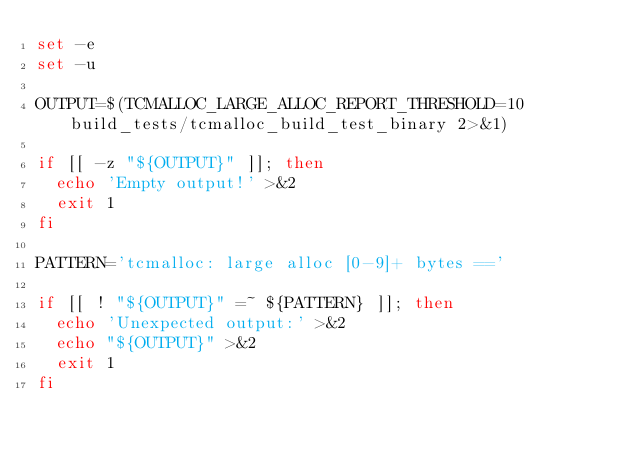Convert code to text. <code><loc_0><loc_0><loc_500><loc_500><_Bash_>set -e
set -u

OUTPUT=$(TCMALLOC_LARGE_ALLOC_REPORT_THRESHOLD=10 build_tests/tcmalloc_build_test_binary 2>&1)

if [[ -z "${OUTPUT}" ]]; then
  echo 'Empty output!' >&2
  exit 1
fi

PATTERN='tcmalloc: large alloc [0-9]+ bytes =='

if [[ ! "${OUTPUT}" =~ ${PATTERN} ]]; then
  echo 'Unexpected output:' >&2
  echo "${OUTPUT}" >&2
  exit 1
fi
</code> 